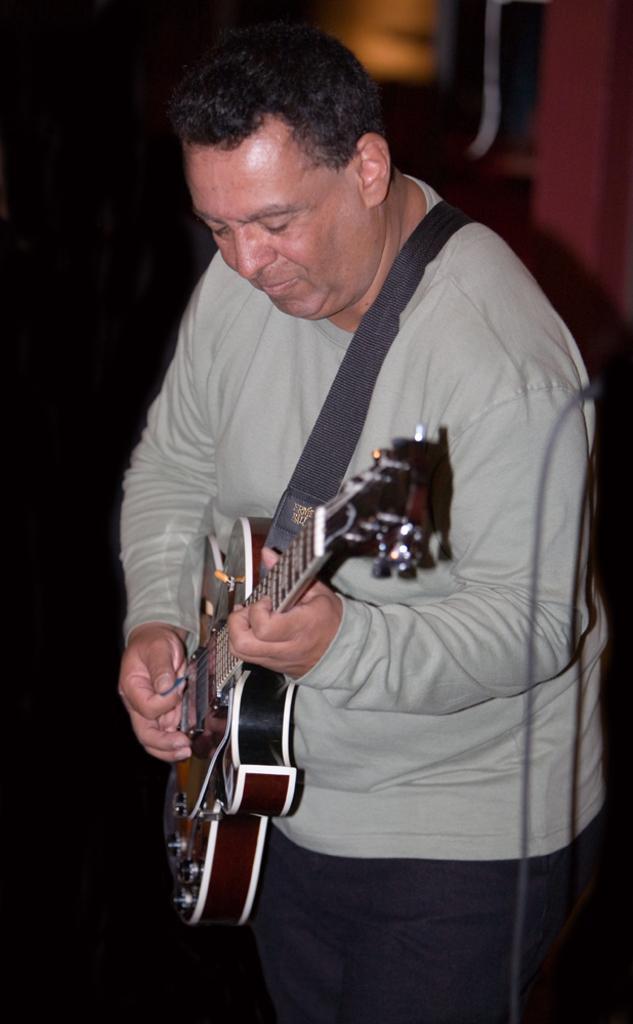Describe this image in one or two sentences. There is a man wearing grey costume holding a guitar and playing in it. 